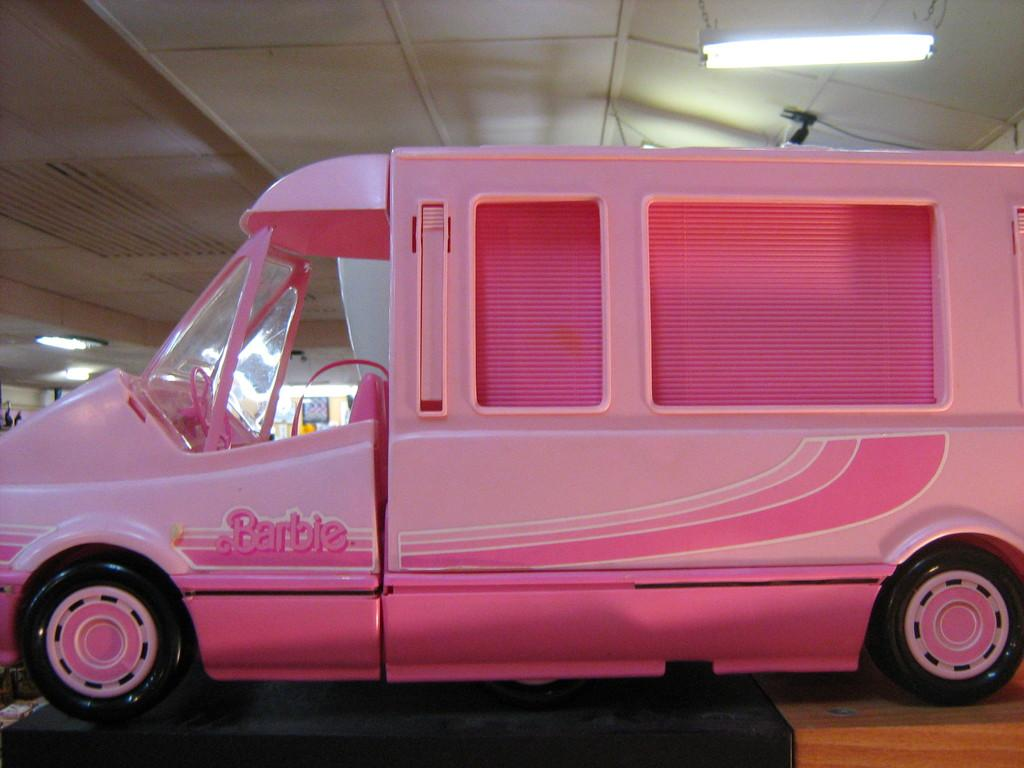What is located on the ground in the image? There is a vehicle on the ground in the image. What can be seen in the background of the image? There is a roof, lights, and some objects visible in the background of the image. Can you see a toad sitting on the roof in the image? No, there is no toad present in the image. What type of poison is being used by the lights in the image? There is no mention of poison in the image; the lights are likely for illumination purposes. 